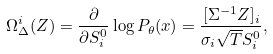Convert formula to latex. <formula><loc_0><loc_0><loc_500><loc_500>\Omega _ { \Delta } ^ { i } ( Z ) = \frac { \partial } { \partial S _ { i } ^ { 0 } } \log P _ { \theta } ( x ) = \frac { [ \Sigma ^ { - 1 } Z ] _ { i } } { \sigma _ { i } \sqrt { T } S _ { i } ^ { 0 } } ,</formula> 